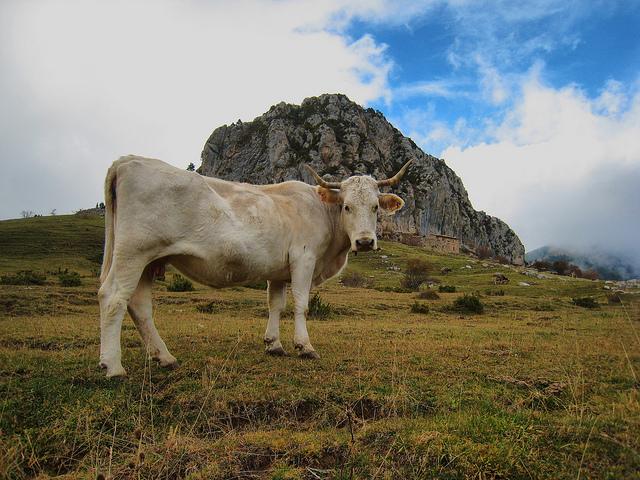What type of animal is pictured?
Answer briefly. Cow. Is the animal having a bell?
Give a very brief answer. No. Is this animal female?
Be succinct. No. Are the hooves of the animal visible?
Short answer required. Yes. How tall is the mountain?
Write a very short answer. Very tall. Might this animal have a problem with visibility?
Short answer required. No. Does this animal eat meat?
Short answer required. No. What's the best appearing to be doing?
Write a very short answer. Standing. How many cows are there?
Answer briefly. 1. There is grass and what else near the animal?
Keep it brief. Mountain. What are the cows eating?
Quick response, please. Grass. How many horns are in this picture?
Write a very short answer. 2. What is the cow eating?
Answer briefly. Grass. What color is the cow?
Write a very short answer. White. How many adult cows are in the photo?
Concise answer only. 1. What animal is that?
Be succinct. Cow. How many cows are in the picture?
Answer briefly. 1. What gender is this animal?
Answer briefly. Male. What color is the little ones fur?
Short answer required. White. Where is this cow?
Quick response, please. Field. Long or short hair?
Write a very short answer. Short. 